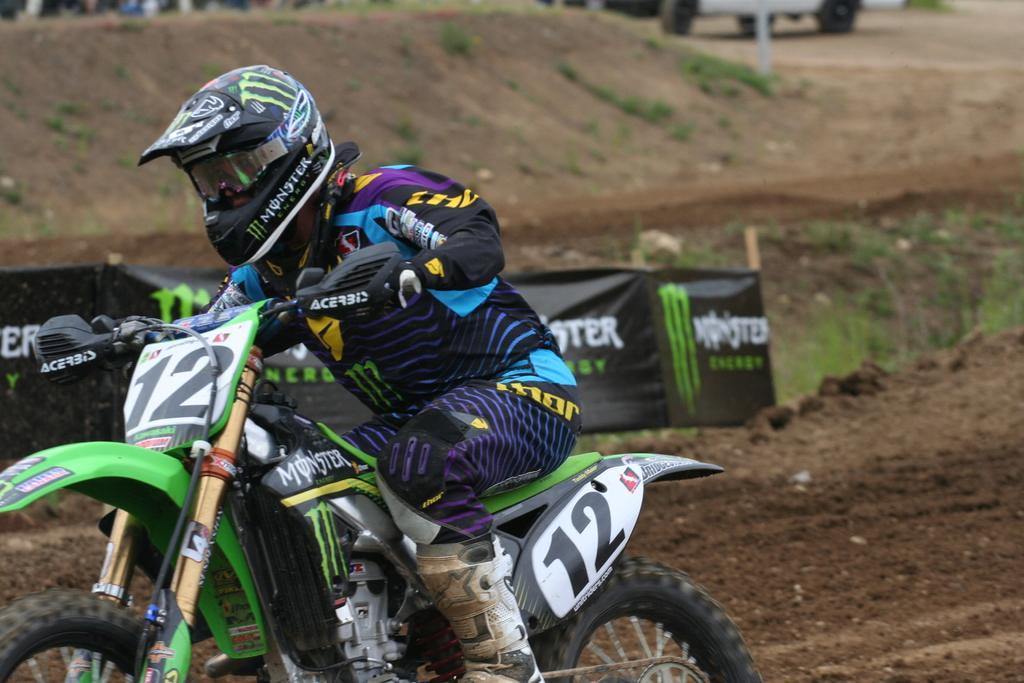Could you give a brief overview of what you see in this image? In this image we can see a person wearing jacket, helmet, gloves, glasses and shoes is riding the bike on the ground. In the background, we can see the mud, banners and this part of the image is slightly blurred. 